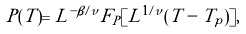<formula> <loc_0><loc_0><loc_500><loc_500>P ( T ) = L ^ { - \beta / \nu } F _ { P } [ L ^ { 1 / \nu } ( T - T _ { p } ) ] ,</formula> 